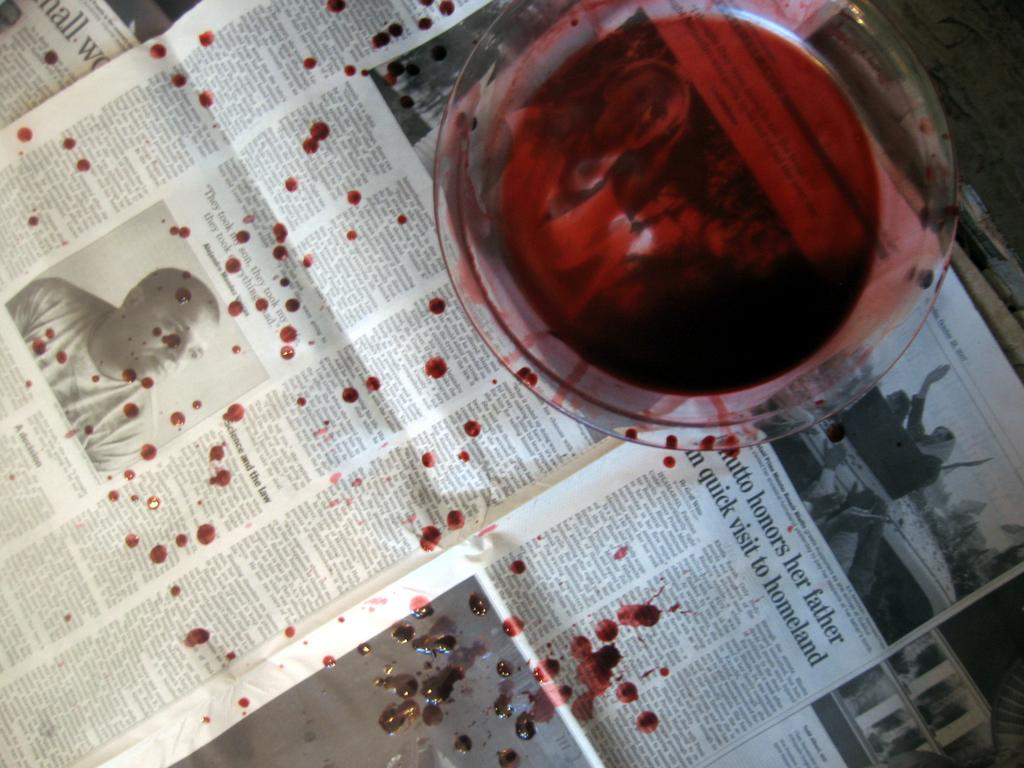<image>
Render a clear and concise summary of the photo. Red cup on top of an article that says "honors" in it. 